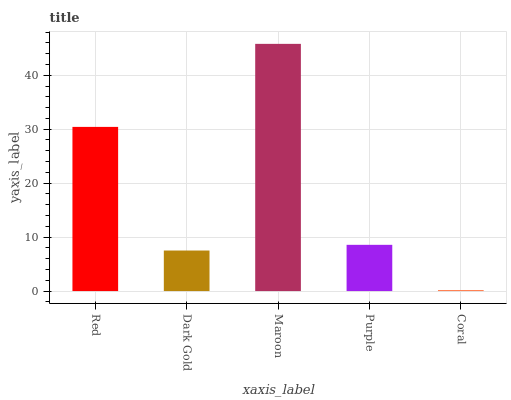Is Coral the minimum?
Answer yes or no. Yes. Is Maroon the maximum?
Answer yes or no. Yes. Is Dark Gold the minimum?
Answer yes or no. No. Is Dark Gold the maximum?
Answer yes or no. No. Is Red greater than Dark Gold?
Answer yes or no. Yes. Is Dark Gold less than Red?
Answer yes or no. Yes. Is Dark Gold greater than Red?
Answer yes or no. No. Is Red less than Dark Gold?
Answer yes or no. No. Is Purple the high median?
Answer yes or no. Yes. Is Purple the low median?
Answer yes or no. Yes. Is Dark Gold the high median?
Answer yes or no. No. Is Dark Gold the low median?
Answer yes or no. No. 